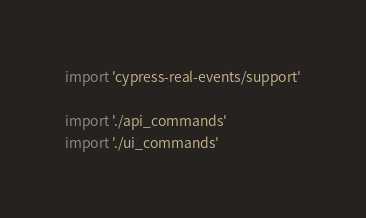Convert code to text. <code><loc_0><loc_0><loc_500><loc_500><_TypeScript_>import 'cypress-real-events/support'

import './api_commands'
import './ui_commands'
</code> 